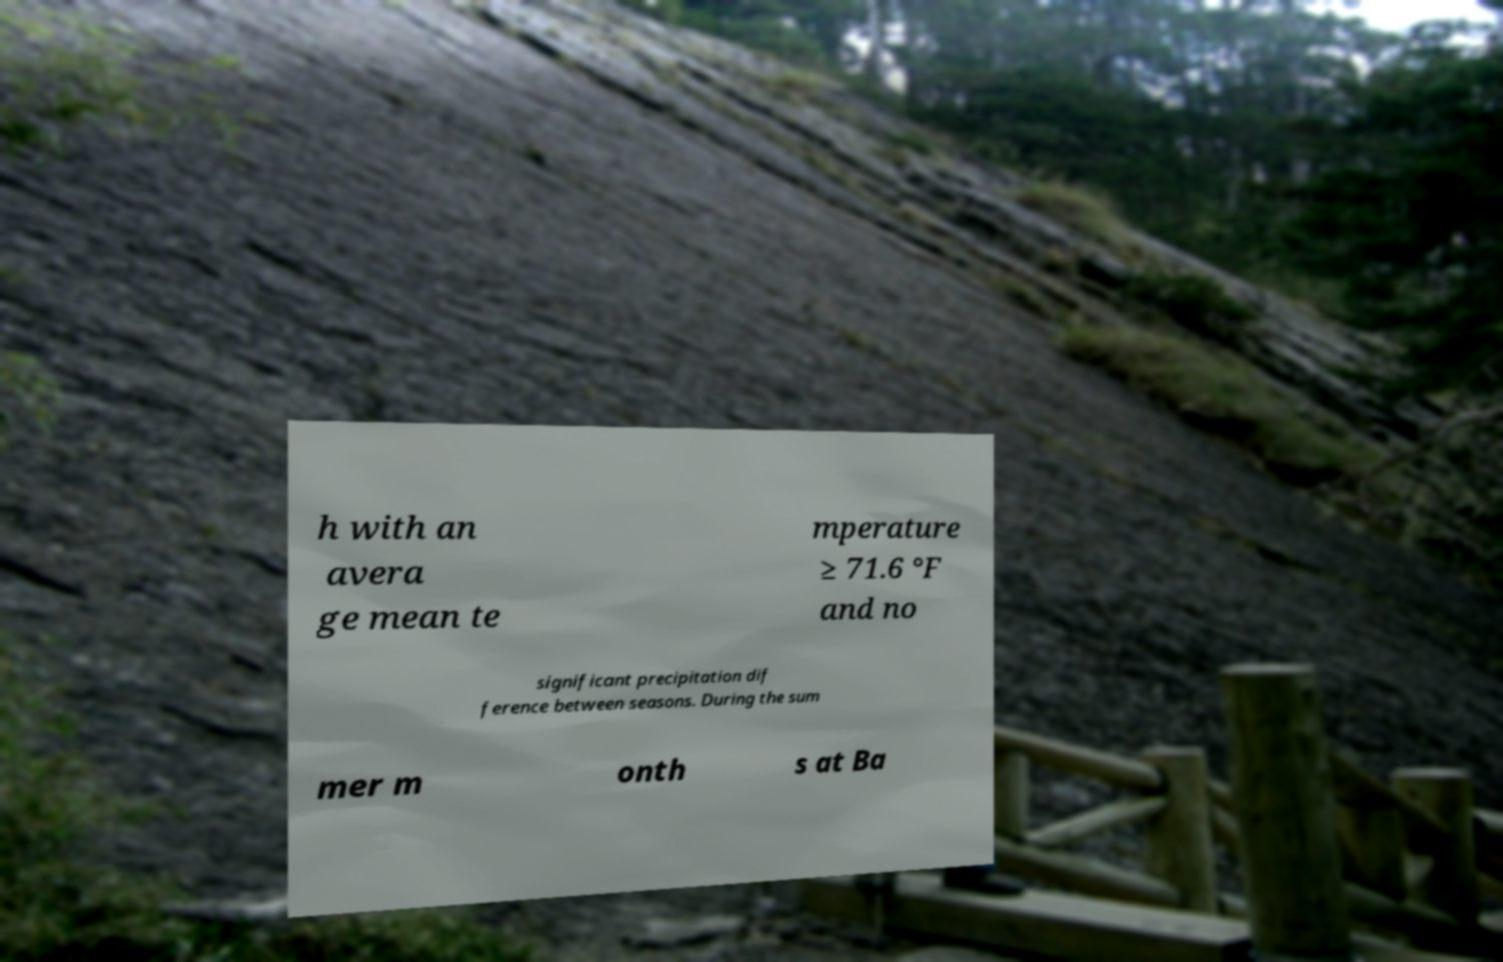I need the written content from this picture converted into text. Can you do that? h with an avera ge mean te mperature ≥ 71.6 °F and no significant precipitation dif ference between seasons. During the sum mer m onth s at Ba 